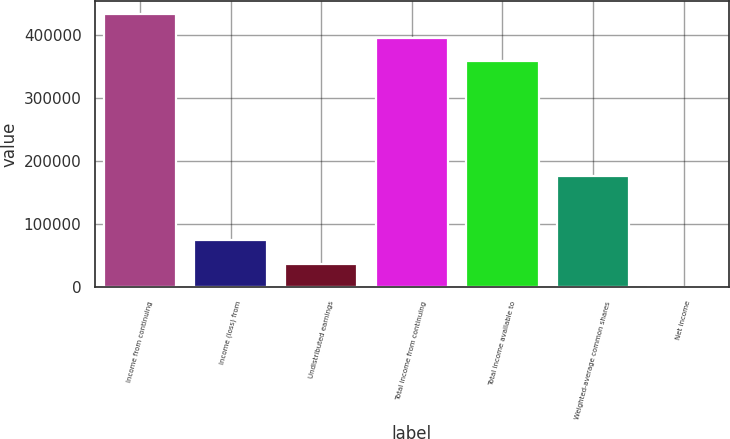Convert chart to OTSL. <chart><loc_0><loc_0><loc_500><loc_500><bar_chart><fcel>Income from continuing<fcel>Income (loss) from<fcel>Undistributed earnings<fcel>Total income from continuing<fcel>Total income available to<fcel>Weighted-average common shares<fcel>Net income<nl><fcel>432776<fcel>74851.6<fcel>37426.8<fcel>395351<fcel>357926<fcel>176445<fcel>2.03<nl></chart> 